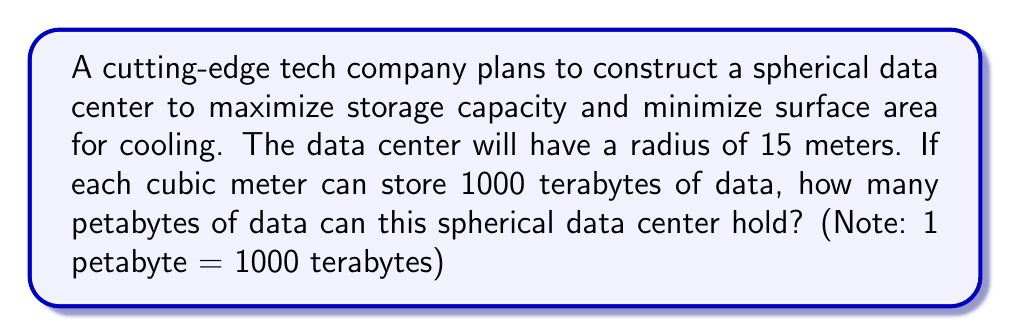Can you solve this math problem? To solve this problem, we need to follow these steps:

1. Calculate the volume of the spherical data center
2. Determine the data storage capacity
3. Convert the result to petabytes

Step 1: Calculate the volume of the sphere
The formula for the volume of a sphere is:

$$V = \frac{4}{3}\pi r^3$$

Where $r$ is the radius of the sphere.

Given $r = 15$ meters, we can calculate:

$$V = \frac{4}{3}\pi (15)^3 = \frac{4}{3}\pi (3375) = 4500\pi \approx 14,137.17 \text{ m}^3$$

Step 2: Determine the data storage capacity
We are given that each cubic meter can store 1000 terabytes of data.
Total storage capacity in terabytes:

$$14,137.17 \text{ m}^3 \times 1000 \text{ TB/m}^3 = 14,137,170 \text{ TB}$$

Step 3: Convert to petabytes
Since 1 petabyte = 1000 terabytes, we divide the result by 1000:

$$14,137,170 \text{ TB} \div 1000 = 14,137.17 \text{ PB}$$

This result gives us the total storage capacity of the spherical data center in petabytes.
Answer: The spherical data center can hold approximately 14,137.17 petabytes of data. 